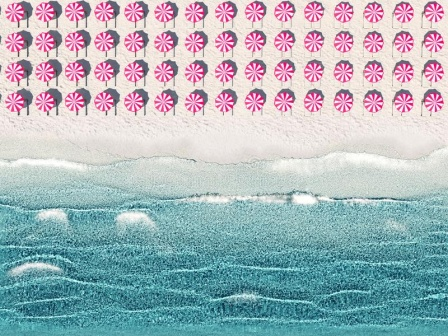What's happening in the scene? The image appears to be an artistic representation of a tranquil beach scene. At the top, there's a vibrant sky filled with patterns resembling pink and white peppermint candies, arranged in neat rows. Moving down, the ocean is depicted with a series of wavy blue lines accented by white, mimicking the look of gentle waves with foam crests. At the bottom, a textured sandy beach in light beige completes the scene, capturing the essence of sand's granular nature. The composition, encased in a white frame, serves as a serene yet whimsical portrayal of a beach, blending elements of nature with imaginative design. 